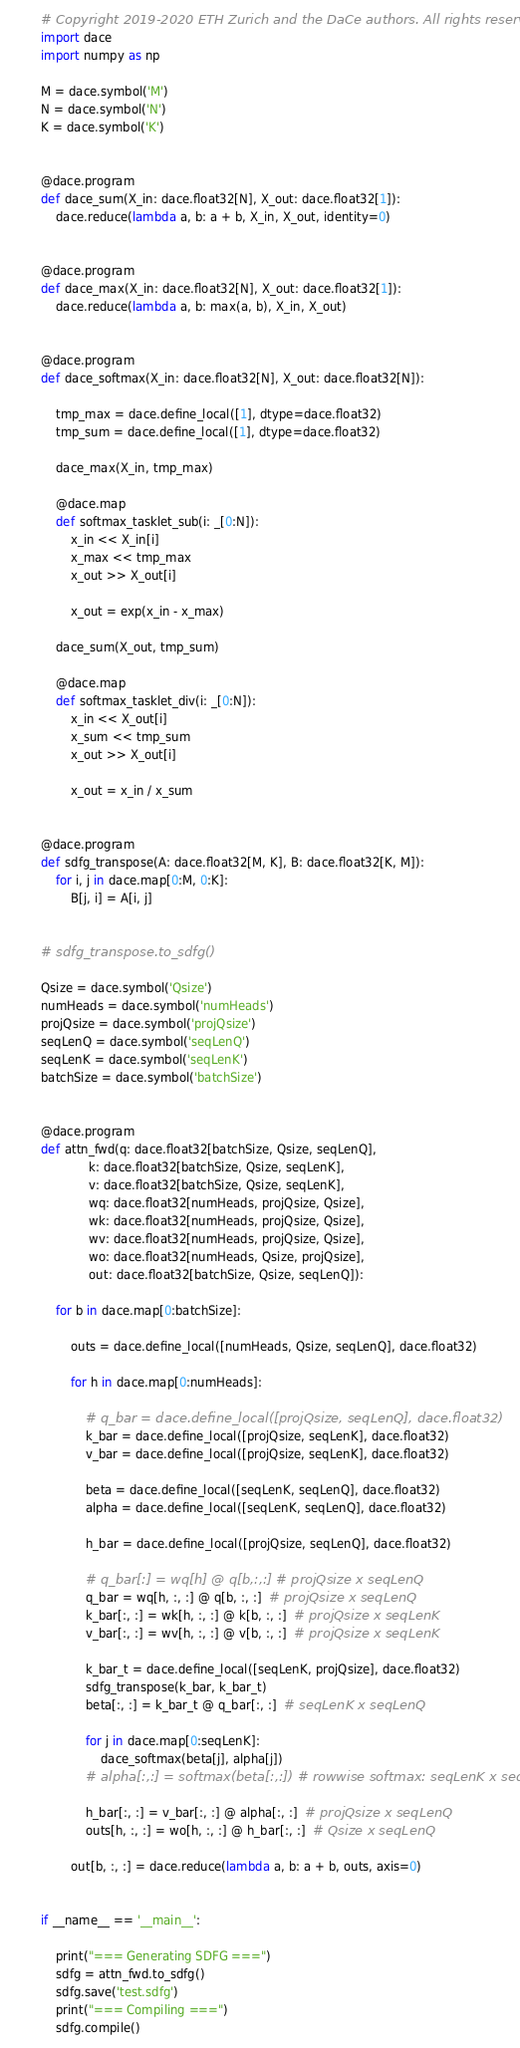<code> <loc_0><loc_0><loc_500><loc_500><_Python_># Copyright 2019-2020 ETH Zurich and the DaCe authors. All rights reserved.
import dace
import numpy as np

M = dace.symbol('M')
N = dace.symbol('N')
K = dace.symbol('K')


@dace.program
def dace_sum(X_in: dace.float32[N], X_out: dace.float32[1]):
    dace.reduce(lambda a, b: a + b, X_in, X_out, identity=0)


@dace.program
def dace_max(X_in: dace.float32[N], X_out: dace.float32[1]):
    dace.reduce(lambda a, b: max(a, b), X_in, X_out)


@dace.program
def dace_softmax(X_in: dace.float32[N], X_out: dace.float32[N]):

    tmp_max = dace.define_local([1], dtype=dace.float32)
    tmp_sum = dace.define_local([1], dtype=dace.float32)

    dace_max(X_in, tmp_max)

    @dace.map
    def softmax_tasklet_sub(i: _[0:N]):
        x_in << X_in[i]
        x_max << tmp_max
        x_out >> X_out[i]

        x_out = exp(x_in - x_max)

    dace_sum(X_out, tmp_sum)

    @dace.map
    def softmax_tasklet_div(i: _[0:N]):
        x_in << X_out[i]
        x_sum << tmp_sum
        x_out >> X_out[i]

        x_out = x_in / x_sum


@dace.program
def sdfg_transpose(A: dace.float32[M, K], B: dace.float32[K, M]):
    for i, j in dace.map[0:M, 0:K]:
        B[j, i] = A[i, j]


# sdfg_transpose.to_sdfg()

Qsize = dace.symbol('Qsize')
numHeads = dace.symbol('numHeads')
projQsize = dace.symbol('projQsize')
seqLenQ = dace.symbol('seqLenQ')
seqLenK = dace.symbol('seqLenK')
batchSize = dace.symbol('batchSize')


@dace.program
def attn_fwd(q: dace.float32[batchSize, Qsize, seqLenQ],
             k: dace.float32[batchSize, Qsize, seqLenK],
             v: dace.float32[batchSize, Qsize, seqLenK],
             wq: dace.float32[numHeads, projQsize, Qsize],
             wk: dace.float32[numHeads, projQsize, Qsize],
             wv: dace.float32[numHeads, projQsize, Qsize],
             wo: dace.float32[numHeads, Qsize, projQsize],
             out: dace.float32[batchSize, Qsize, seqLenQ]):

    for b in dace.map[0:batchSize]:

        outs = dace.define_local([numHeads, Qsize, seqLenQ], dace.float32)

        for h in dace.map[0:numHeads]:

            # q_bar = dace.define_local([projQsize, seqLenQ], dace.float32)
            k_bar = dace.define_local([projQsize, seqLenK], dace.float32)
            v_bar = dace.define_local([projQsize, seqLenK], dace.float32)

            beta = dace.define_local([seqLenK, seqLenQ], dace.float32)
            alpha = dace.define_local([seqLenK, seqLenQ], dace.float32)

            h_bar = dace.define_local([projQsize, seqLenQ], dace.float32)

            # q_bar[:] = wq[h] @ q[b,:,:] # projQsize x seqLenQ
            q_bar = wq[h, :, :] @ q[b, :, :]  # projQsize x seqLenQ
            k_bar[:, :] = wk[h, :, :] @ k[b, :, :]  # projQsize x seqLenK
            v_bar[:, :] = wv[h, :, :] @ v[b, :, :]  # projQsize x seqLenK

            k_bar_t = dace.define_local([seqLenK, projQsize], dace.float32)
            sdfg_transpose(k_bar, k_bar_t)
            beta[:, :] = k_bar_t @ q_bar[:, :]  # seqLenK x seqLenQ

            for j in dace.map[0:seqLenK]:
                dace_softmax(beta[j], alpha[j])
            # alpha[:,:] = softmax(beta[:,:]) # rowwise softmax: seqLenK x seqLenQ

            h_bar[:, :] = v_bar[:, :] @ alpha[:, :]  # projQsize x seqLenQ
            outs[h, :, :] = wo[h, :, :] @ h_bar[:, :]  # Qsize x seqLenQ

        out[b, :, :] = dace.reduce(lambda a, b: a + b, outs, axis=0)


if __name__ == '__main__':

    print("=== Generating SDFG ===")
    sdfg = attn_fwd.to_sdfg()
    sdfg.save('test.sdfg')
    print("=== Compiling ===")
    sdfg.compile()
</code> 